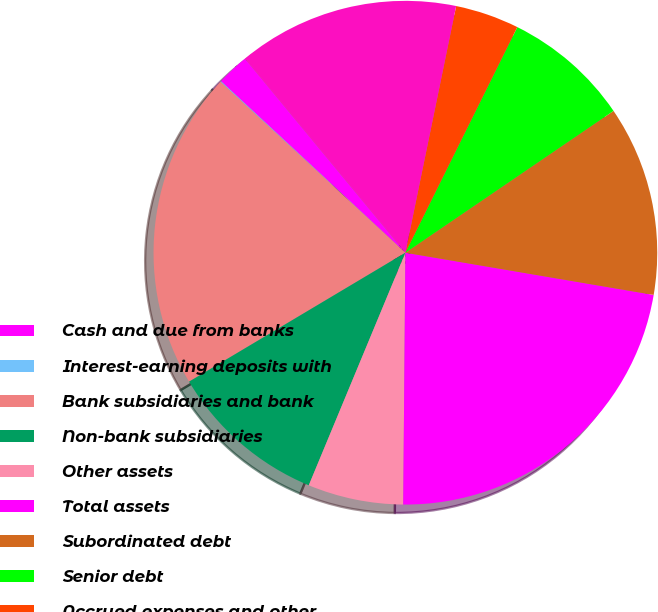<chart> <loc_0><loc_0><loc_500><loc_500><pie_chart><fcel>Cash and due from banks<fcel>Interest-earning deposits with<fcel>Bank subsidiaries and bank<fcel>Non-bank subsidiaries<fcel>Other assets<fcel>Total assets<fcel>Subordinated debt<fcel>Senior debt<fcel>Accrued expenses and other<fcel>Total liabilities<nl><fcel>2.08%<fcel>0.05%<fcel>20.43%<fcel>10.18%<fcel>6.13%<fcel>22.46%<fcel>12.2%<fcel>8.15%<fcel>4.1%<fcel>14.23%<nl></chart> 